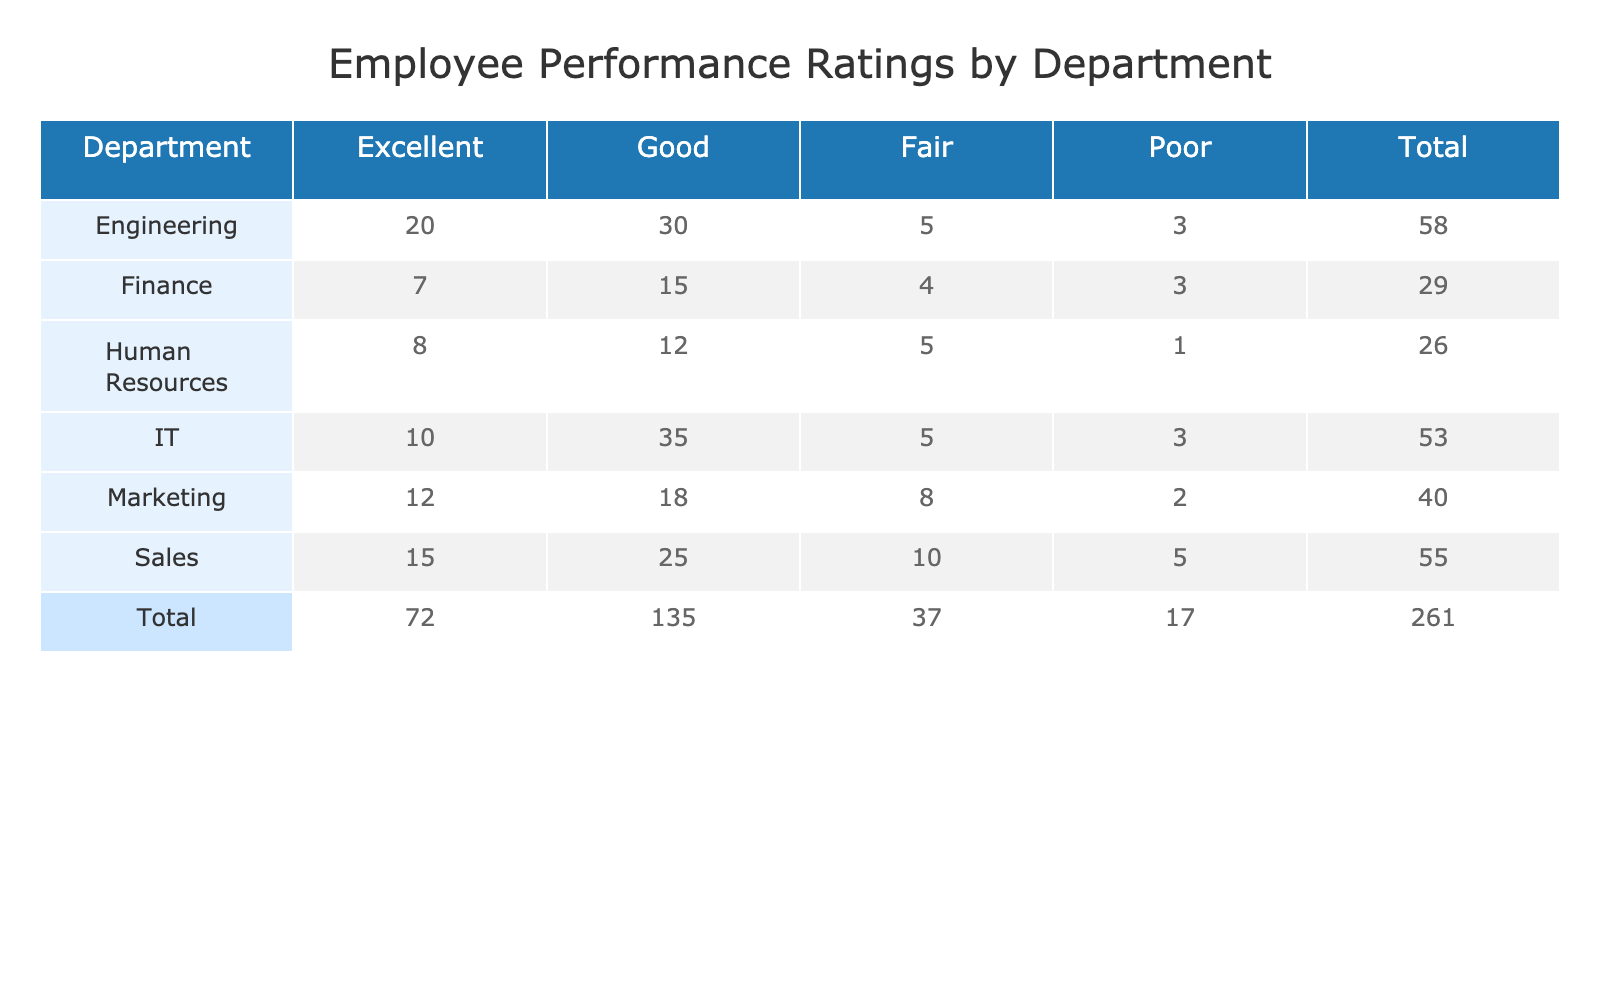What is the total number of employees rated as Excellent in the Sales department? The Sales department has 15 employees rated as Excellent. This is directly taken from the table under the Sales row in the Excellent column.
Answer: 15 How many employees in total were rated as Good across all departments? We need to sum the frequencies of the Good ratings from all departments: Sales (25) + Marketing (18) + Engineering (30) + IT (35) + Human Resources (12) + Finance (15) = 135.
Answer: 135 Is there any department where no employees were rated as Poor? Looking at the table, the Marketing department has 2 employees rated as Poor, Sales has 5, Engineering has 3, IT has 3, Human Resources has 1, and Finance has 3. All departments have some Poor ratings.
Answer: No What department has the highest frequency of employees rated as Fair? In the table, the Fair ratings are: Sales (10), Marketing (8), Engineering (5), IT (5), Human Resources (5), and Finance (4). The Sales department has the highest Fair rating with 10 employees.
Answer: Sales What is the average performance rating across all departments for employees rated as Excellent? The total number of employees rated as Excellent is: Sales (15) + Marketing (12) + Engineering (20) + IT (10) + Human Resources (8) + Finance (7) = 72. There are 6 departments, so the average is 72/6 = 12.
Answer: 12 Which department has the lowest total number of employees rated across all performance levels? First, we calculate the total for each department: Sales (55), Marketing (40), Engineering (58), IT (53), Human Resources (36), and Finance (29). The Finance department has the lowest total with 29 employees.
Answer: Finance What is the difference between the number of employees rated as Good and those rated as Fair in the Engineering department? The Engineering department has 30 employees rated as Good and 5 rated as Fair. The difference is calculated as 30 - 5 = 25.
Answer: 25 Are there more employees rated as Excellent in the Engineering department than in Human Resources? The Engineering department has 20 employees rated as Excellent, while Human Resources has 8. Since 20 is greater than 8, the statement is true.
Answer: Yes How many more employees are rated as Good in IT than in Marketing? The IT department has 35 employees rated as Good compared to Marketing's 18. The difference is calculated as 35 - 18 = 17.
Answer: 17 